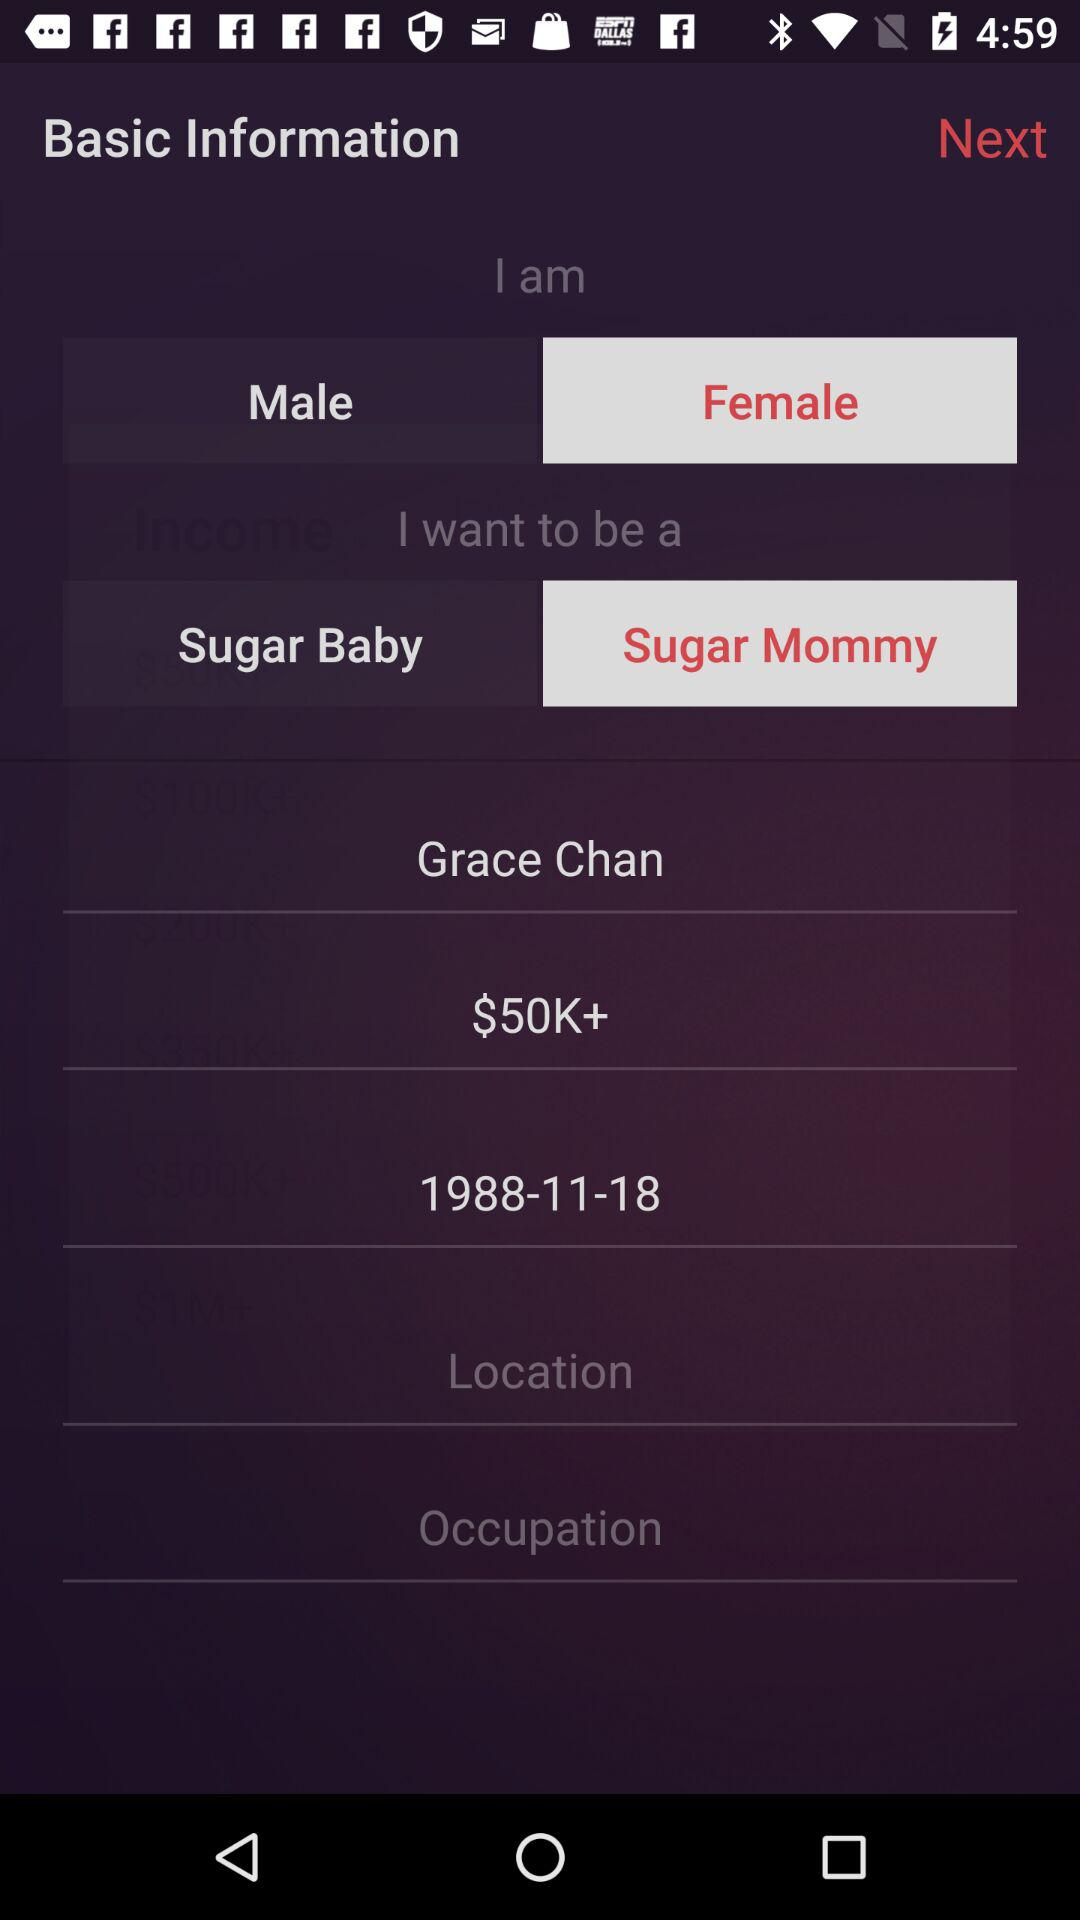What are the gender options? The gender options are male and female. 